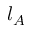Convert formula to latex. <formula><loc_0><loc_0><loc_500><loc_500>l _ { A }</formula> 